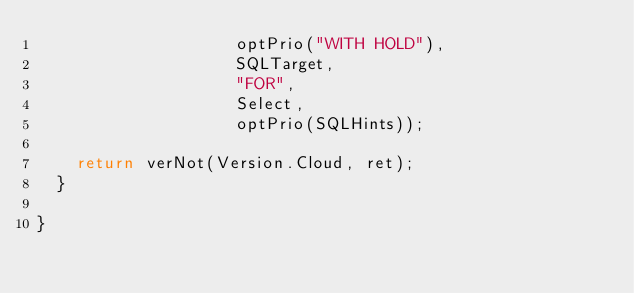Convert code to text. <code><loc_0><loc_0><loc_500><loc_500><_TypeScript_>                    optPrio("WITH HOLD"),
                    SQLTarget,
                    "FOR",
                    Select,
                    optPrio(SQLHints));

    return verNot(Version.Cloud, ret);
  }

}</code> 